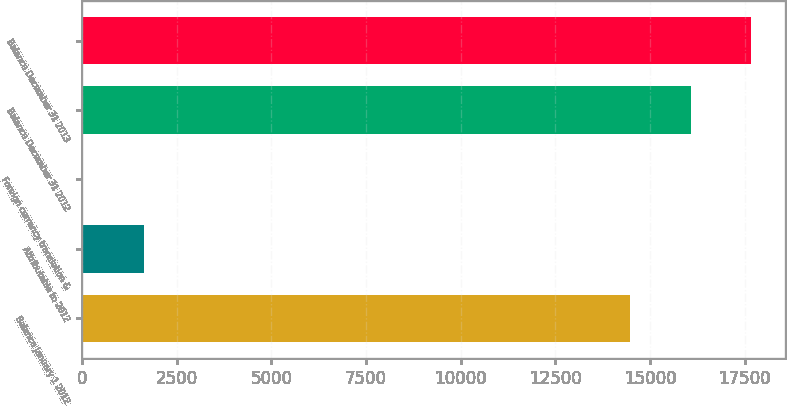<chart> <loc_0><loc_0><loc_500><loc_500><bar_chart><fcel>Balance January 1 2012<fcel>Attributable to 2012<fcel>Foreign currency translation &<fcel>Balance December 31 2012<fcel>Balance December 31 2013<nl><fcel>14474.3<fcel>1629.02<fcel>28<fcel>16075.3<fcel>17676.3<nl></chart> 